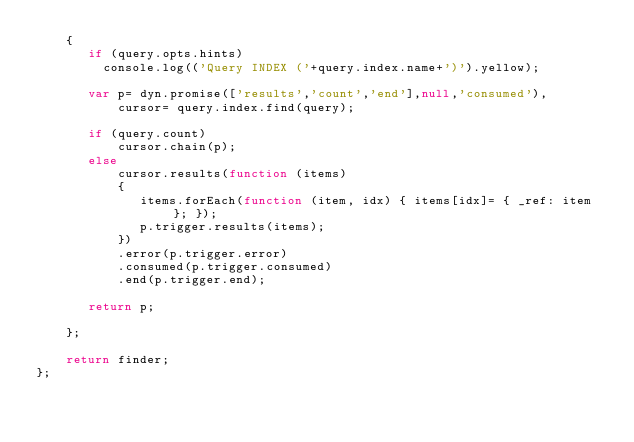Convert code to text. <code><loc_0><loc_0><loc_500><loc_500><_JavaScript_>    {
       if (query.opts.hints)
         console.log(('Query INDEX ('+query.index.name+')').yellow);

       var p= dyn.promise(['results','count','end'],null,'consumed'),
           cursor= query.index.find(query);

       if (query.count)
           cursor.chain(p);
       else
           cursor.results(function (items)
           {
              items.forEach(function (item, idx) { items[idx]= { _ref: item }; }); 
              p.trigger.results(items);
           })
           .error(p.trigger.error)
           .consumed(p.trigger.consumed)
           .end(p.trigger.end);

       return p;

    };

    return finder;
};
</code> 